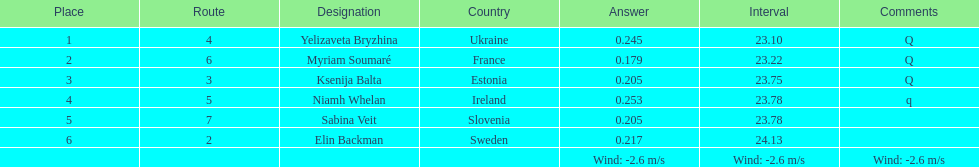How many surnames begin with "b"? 3. 